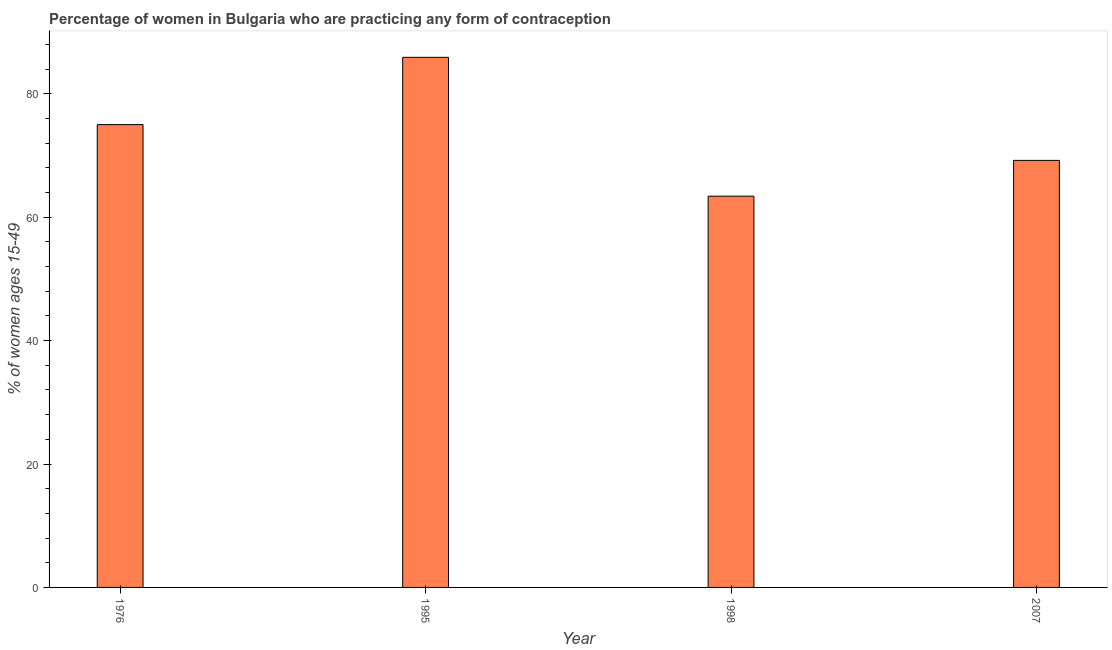Does the graph contain any zero values?
Your response must be concise. No. What is the title of the graph?
Provide a short and direct response. Percentage of women in Bulgaria who are practicing any form of contraception. What is the label or title of the Y-axis?
Your answer should be compact. % of women ages 15-49. What is the contraceptive prevalence in 1976?
Provide a short and direct response. 75. Across all years, what is the maximum contraceptive prevalence?
Offer a terse response. 85.9. Across all years, what is the minimum contraceptive prevalence?
Your response must be concise. 63.4. In which year was the contraceptive prevalence minimum?
Give a very brief answer. 1998. What is the sum of the contraceptive prevalence?
Provide a short and direct response. 293.5. What is the difference between the contraceptive prevalence in 1976 and 1995?
Offer a terse response. -10.9. What is the average contraceptive prevalence per year?
Your response must be concise. 73.38. What is the median contraceptive prevalence?
Ensure brevity in your answer.  72.1. Do a majority of the years between 1976 and 1998 (inclusive) have contraceptive prevalence greater than 52 %?
Your answer should be compact. Yes. What is the ratio of the contraceptive prevalence in 1995 to that in 2007?
Offer a terse response. 1.24. Is the contraceptive prevalence in 1998 less than that in 2007?
Ensure brevity in your answer.  Yes. Is the difference between the contraceptive prevalence in 1976 and 2007 greater than the difference between any two years?
Offer a very short reply. No. What is the difference between the highest and the second highest contraceptive prevalence?
Your answer should be very brief. 10.9. Is the sum of the contraceptive prevalence in 1995 and 2007 greater than the maximum contraceptive prevalence across all years?
Offer a very short reply. Yes. What is the difference between the highest and the lowest contraceptive prevalence?
Provide a short and direct response. 22.5. In how many years, is the contraceptive prevalence greater than the average contraceptive prevalence taken over all years?
Your answer should be compact. 2. How many bars are there?
Provide a succinct answer. 4. Are all the bars in the graph horizontal?
Offer a very short reply. No. How many years are there in the graph?
Make the answer very short. 4. What is the difference between two consecutive major ticks on the Y-axis?
Offer a terse response. 20. Are the values on the major ticks of Y-axis written in scientific E-notation?
Keep it short and to the point. No. What is the % of women ages 15-49 in 1995?
Make the answer very short. 85.9. What is the % of women ages 15-49 in 1998?
Make the answer very short. 63.4. What is the % of women ages 15-49 in 2007?
Offer a terse response. 69.2. What is the difference between the % of women ages 15-49 in 1976 and 1995?
Your answer should be compact. -10.9. What is the difference between the % of women ages 15-49 in 1976 and 2007?
Make the answer very short. 5.8. What is the ratio of the % of women ages 15-49 in 1976 to that in 1995?
Give a very brief answer. 0.87. What is the ratio of the % of women ages 15-49 in 1976 to that in 1998?
Provide a short and direct response. 1.18. What is the ratio of the % of women ages 15-49 in 1976 to that in 2007?
Give a very brief answer. 1.08. What is the ratio of the % of women ages 15-49 in 1995 to that in 1998?
Your answer should be compact. 1.35. What is the ratio of the % of women ages 15-49 in 1995 to that in 2007?
Make the answer very short. 1.24. What is the ratio of the % of women ages 15-49 in 1998 to that in 2007?
Your answer should be very brief. 0.92. 